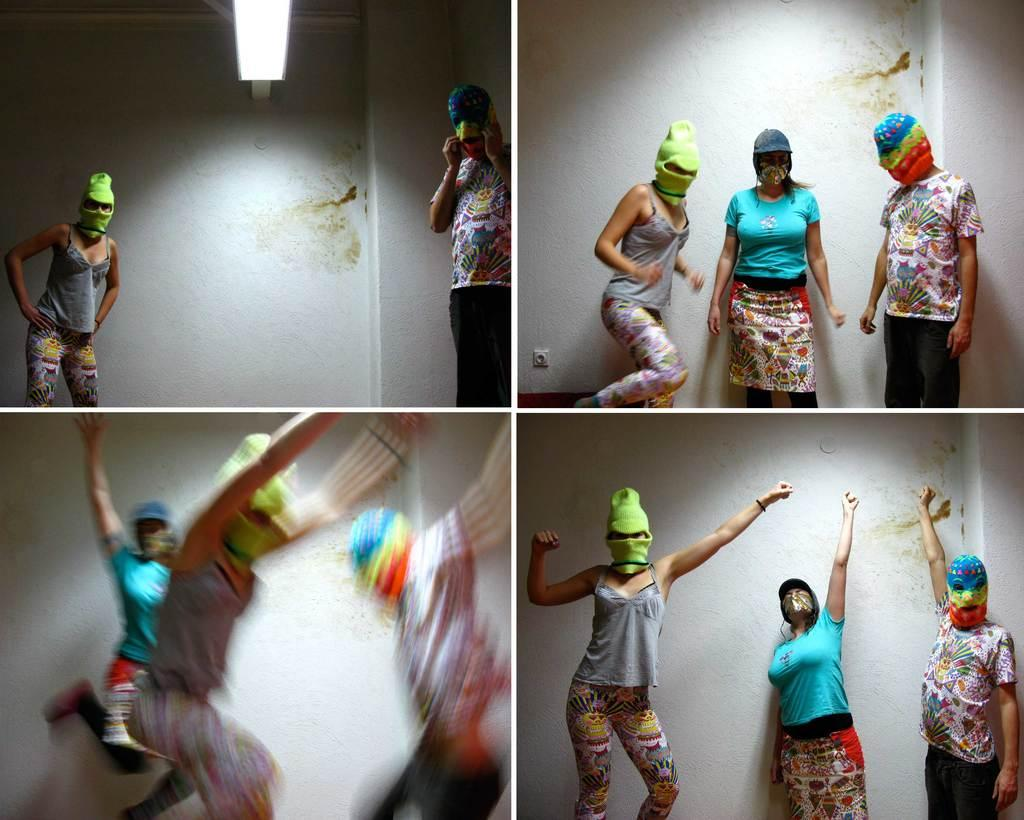How many people are in the image? There is a group of people in the image. What are the people wearing on their faces? The people are wearing masks on their faces. What can be seen on the wall in the image? There are lights on a wall in the image. How does the ant contribute to the digestion process of the people in the image? There are no ants present in the image, and therefore no such interaction can be observed. 